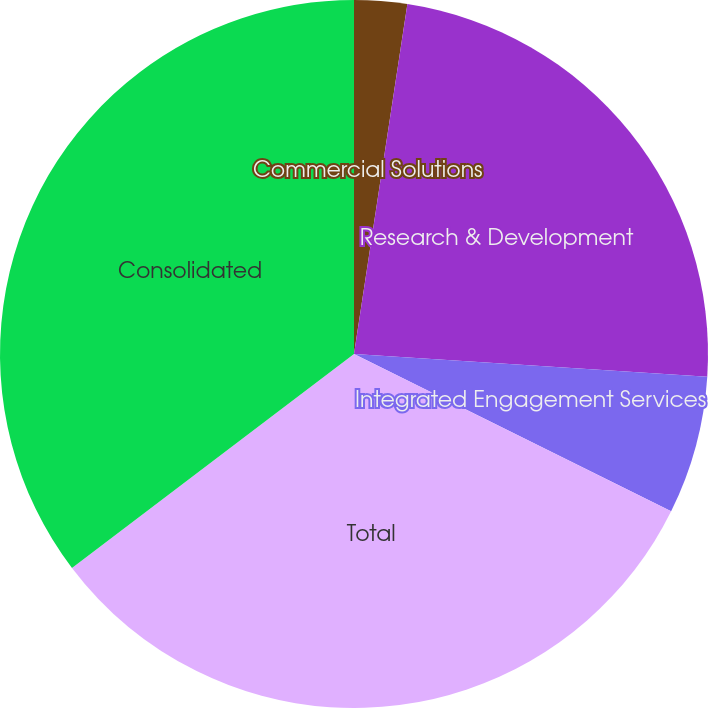Convert chart to OTSL. <chart><loc_0><loc_0><loc_500><loc_500><pie_chart><fcel>Commercial Solutions<fcel>Research & Development<fcel>Integrated Engagement Services<fcel>Total<fcel>Consolidated<nl><fcel>2.41%<fcel>23.61%<fcel>6.31%<fcel>32.34%<fcel>35.33%<nl></chart> 